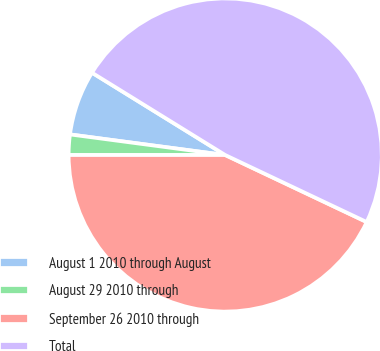<chart> <loc_0><loc_0><loc_500><loc_500><pie_chart><fcel>August 1 2010 through August<fcel>August 29 2010 through<fcel>September 26 2010 through<fcel>Total<nl><fcel>6.71%<fcel>2.1%<fcel>42.96%<fcel>48.23%<nl></chart> 